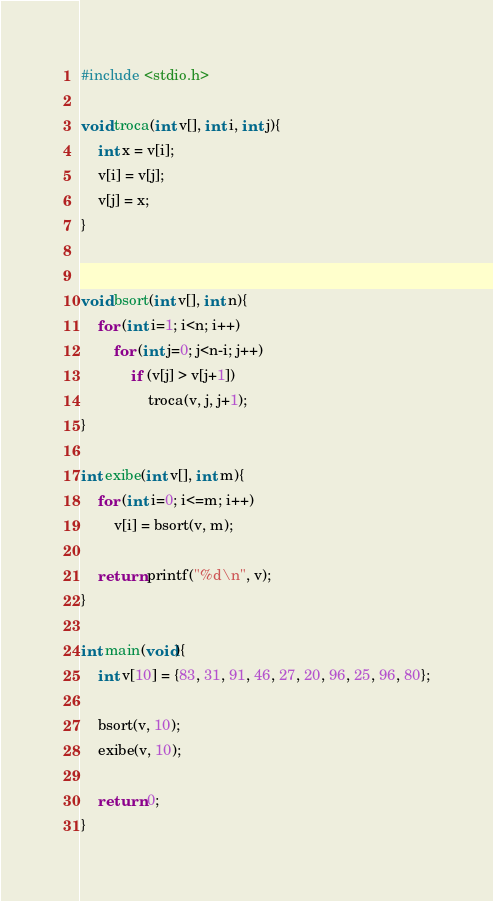Convert code to text. <code><loc_0><loc_0><loc_500><loc_500><_C_>#include <stdio.h>

void troca(int v[], int i, int j){
    int x = v[i];
    v[i] = v[j];
    v[j] = x;
}


void bsort(int v[], int n){
    for (int i=1; i<n; i++)
        for (int j=0; j<n-i; j++)
            if (v[j] > v[j+1])
                troca(v, j, j+1);
}

int exibe(int v[], int m){
    for (int i=0; i<=m; i++)
        v[i] = bsort(v, m);
    
    return printf("%d\n", v);  
}

int main(void){
    int v[10] = {83, 31, 91, 46, 27, 20, 96, 25, 96, 80};

    bsort(v, 10);
    exibe(v, 10);

    return 0;
}</code> 